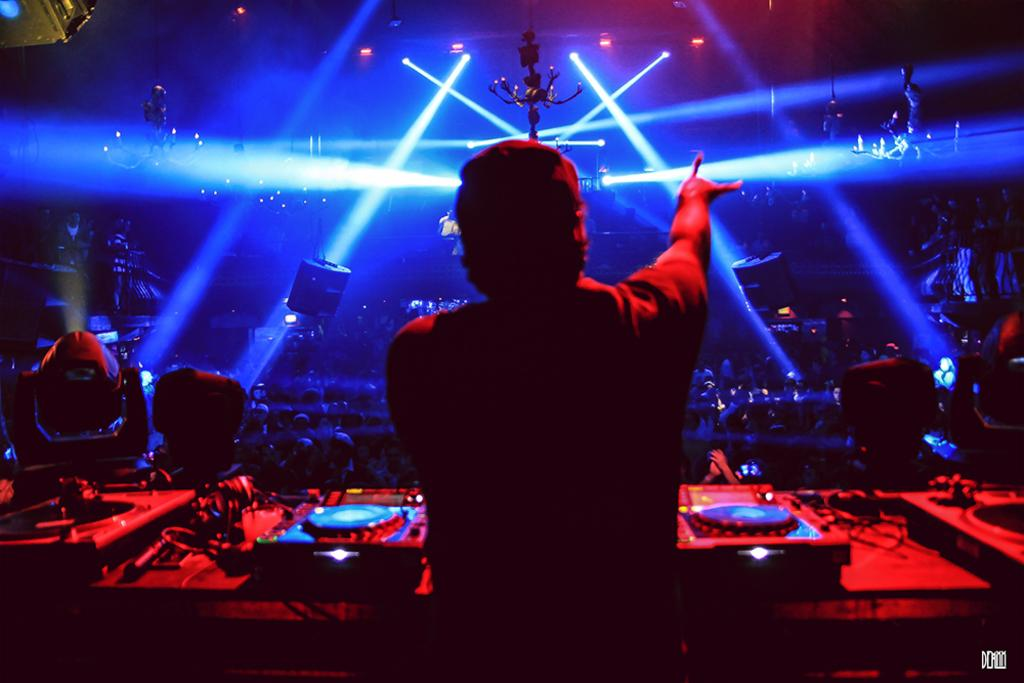What is the main subject of the image? There is a person in front of musical equipment in the image. Can you describe the other people in the image? There are other persons in the middle of the image. What can be seen at the top of the image? There are lights at the top of the image. How many legs does the insect have in the image? There is no insect present in the image. 